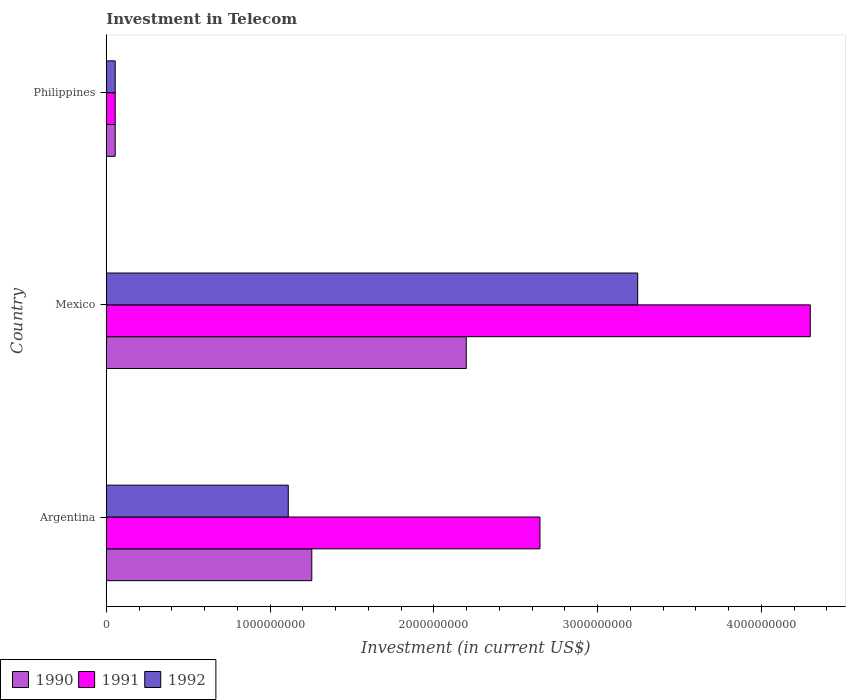How many groups of bars are there?
Offer a very short reply. 3. Are the number of bars on each tick of the Y-axis equal?
Your answer should be very brief. Yes. How many bars are there on the 3rd tick from the top?
Give a very brief answer. 3. What is the label of the 1st group of bars from the top?
Provide a succinct answer. Philippines. What is the amount invested in telecom in 1990 in Argentina?
Your response must be concise. 1.25e+09. Across all countries, what is the maximum amount invested in telecom in 1990?
Keep it short and to the point. 2.20e+09. Across all countries, what is the minimum amount invested in telecom in 1992?
Your answer should be compact. 5.42e+07. In which country was the amount invested in telecom in 1991 maximum?
Provide a short and direct response. Mexico. In which country was the amount invested in telecom in 1990 minimum?
Your answer should be very brief. Philippines. What is the total amount invested in telecom in 1992 in the graph?
Your response must be concise. 4.41e+09. What is the difference between the amount invested in telecom in 1992 in Mexico and that in Philippines?
Provide a short and direct response. 3.19e+09. What is the difference between the amount invested in telecom in 1992 in Philippines and the amount invested in telecom in 1991 in Mexico?
Ensure brevity in your answer.  -4.24e+09. What is the average amount invested in telecom in 1991 per country?
Make the answer very short. 2.33e+09. What is the difference between the amount invested in telecom in 1992 and amount invested in telecom in 1991 in Argentina?
Your response must be concise. -1.54e+09. What is the ratio of the amount invested in telecom in 1990 in Mexico to that in Philippines?
Your response must be concise. 40.55. Is the amount invested in telecom in 1992 in Argentina less than that in Philippines?
Give a very brief answer. No. Is the difference between the amount invested in telecom in 1992 in Argentina and Philippines greater than the difference between the amount invested in telecom in 1991 in Argentina and Philippines?
Offer a very short reply. No. What is the difference between the highest and the second highest amount invested in telecom in 1992?
Provide a succinct answer. 2.13e+09. What is the difference between the highest and the lowest amount invested in telecom in 1991?
Ensure brevity in your answer.  4.24e+09. Is it the case that in every country, the sum of the amount invested in telecom in 1992 and amount invested in telecom in 1991 is greater than the amount invested in telecom in 1990?
Make the answer very short. Yes. How many bars are there?
Offer a terse response. 9. Are all the bars in the graph horizontal?
Your answer should be very brief. Yes. What is the difference between two consecutive major ticks on the X-axis?
Offer a terse response. 1.00e+09. Are the values on the major ticks of X-axis written in scientific E-notation?
Offer a very short reply. No. Where does the legend appear in the graph?
Provide a succinct answer. Bottom left. What is the title of the graph?
Your response must be concise. Investment in Telecom. What is the label or title of the X-axis?
Ensure brevity in your answer.  Investment (in current US$). What is the label or title of the Y-axis?
Offer a terse response. Country. What is the Investment (in current US$) in 1990 in Argentina?
Your answer should be very brief. 1.25e+09. What is the Investment (in current US$) of 1991 in Argentina?
Offer a terse response. 2.65e+09. What is the Investment (in current US$) of 1992 in Argentina?
Offer a terse response. 1.11e+09. What is the Investment (in current US$) in 1990 in Mexico?
Provide a succinct answer. 2.20e+09. What is the Investment (in current US$) of 1991 in Mexico?
Make the answer very short. 4.30e+09. What is the Investment (in current US$) in 1992 in Mexico?
Your response must be concise. 3.24e+09. What is the Investment (in current US$) of 1990 in Philippines?
Ensure brevity in your answer.  5.42e+07. What is the Investment (in current US$) in 1991 in Philippines?
Your answer should be compact. 5.42e+07. What is the Investment (in current US$) of 1992 in Philippines?
Offer a terse response. 5.42e+07. Across all countries, what is the maximum Investment (in current US$) in 1990?
Ensure brevity in your answer.  2.20e+09. Across all countries, what is the maximum Investment (in current US$) of 1991?
Your answer should be very brief. 4.30e+09. Across all countries, what is the maximum Investment (in current US$) in 1992?
Your answer should be very brief. 3.24e+09. Across all countries, what is the minimum Investment (in current US$) in 1990?
Your answer should be very brief. 5.42e+07. Across all countries, what is the minimum Investment (in current US$) of 1991?
Provide a short and direct response. 5.42e+07. Across all countries, what is the minimum Investment (in current US$) in 1992?
Your response must be concise. 5.42e+07. What is the total Investment (in current US$) of 1990 in the graph?
Make the answer very short. 3.51e+09. What is the total Investment (in current US$) of 1991 in the graph?
Your response must be concise. 7.00e+09. What is the total Investment (in current US$) in 1992 in the graph?
Provide a succinct answer. 4.41e+09. What is the difference between the Investment (in current US$) in 1990 in Argentina and that in Mexico?
Keep it short and to the point. -9.43e+08. What is the difference between the Investment (in current US$) in 1991 in Argentina and that in Mexico?
Ensure brevity in your answer.  -1.65e+09. What is the difference between the Investment (in current US$) of 1992 in Argentina and that in Mexico?
Provide a succinct answer. -2.13e+09. What is the difference between the Investment (in current US$) of 1990 in Argentina and that in Philippines?
Provide a succinct answer. 1.20e+09. What is the difference between the Investment (in current US$) in 1991 in Argentina and that in Philippines?
Ensure brevity in your answer.  2.59e+09. What is the difference between the Investment (in current US$) in 1992 in Argentina and that in Philippines?
Give a very brief answer. 1.06e+09. What is the difference between the Investment (in current US$) of 1990 in Mexico and that in Philippines?
Make the answer very short. 2.14e+09. What is the difference between the Investment (in current US$) in 1991 in Mexico and that in Philippines?
Your response must be concise. 4.24e+09. What is the difference between the Investment (in current US$) in 1992 in Mexico and that in Philippines?
Make the answer very short. 3.19e+09. What is the difference between the Investment (in current US$) in 1990 in Argentina and the Investment (in current US$) in 1991 in Mexico?
Your answer should be compact. -3.04e+09. What is the difference between the Investment (in current US$) in 1990 in Argentina and the Investment (in current US$) in 1992 in Mexico?
Offer a very short reply. -1.99e+09. What is the difference between the Investment (in current US$) of 1991 in Argentina and the Investment (in current US$) of 1992 in Mexico?
Make the answer very short. -5.97e+08. What is the difference between the Investment (in current US$) of 1990 in Argentina and the Investment (in current US$) of 1991 in Philippines?
Offer a terse response. 1.20e+09. What is the difference between the Investment (in current US$) in 1990 in Argentina and the Investment (in current US$) in 1992 in Philippines?
Provide a succinct answer. 1.20e+09. What is the difference between the Investment (in current US$) in 1991 in Argentina and the Investment (in current US$) in 1992 in Philippines?
Keep it short and to the point. 2.59e+09. What is the difference between the Investment (in current US$) of 1990 in Mexico and the Investment (in current US$) of 1991 in Philippines?
Give a very brief answer. 2.14e+09. What is the difference between the Investment (in current US$) of 1990 in Mexico and the Investment (in current US$) of 1992 in Philippines?
Keep it short and to the point. 2.14e+09. What is the difference between the Investment (in current US$) in 1991 in Mexico and the Investment (in current US$) in 1992 in Philippines?
Give a very brief answer. 4.24e+09. What is the average Investment (in current US$) of 1990 per country?
Your answer should be compact. 1.17e+09. What is the average Investment (in current US$) in 1991 per country?
Provide a succinct answer. 2.33e+09. What is the average Investment (in current US$) in 1992 per country?
Offer a terse response. 1.47e+09. What is the difference between the Investment (in current US$) in 1990 and Investment (in current US$) in 1991 in Argentina?
Offer a terse response. -1.39e+09. What is the difference between the Investment (in current US$) of 1990 and Investment (in current US$) of 1992 in Argentina?
Your response must be concise. 1.44e+08. What is the difference between the Investment (in current US$) in 1991 and Investment (in current US$) in 1992 in Argentina?
Provide a short and direct response. 1.54e+09. What is the difference between the Investment (in current US$) in 1990 and Investment (in current US$) in 1991 in Mexico?
Your answer should be very brief. -2.10e+09. What is the difference between the Investment (in current US$) in 1990 and Investment (in current US$) in 1992 in Mexico?
Ensure brevity in your answer.  -1.05e+09. What is the difference between the Investment (in current US$) of 1991 and Investment (in current US$) of 1992 in Mexico?
Your response must be concise. 1.05e+09. What is the difference between the Investment (in current US$) in 1990 and Investment (in current US$) in 1991 in Philippines?
Offer a very short reply. 0. What is the difference between the Investment (in current US$) in 1990 and Investment (in current US$) in 1992 in Philippines?
Your response must be concise. 0. What is the difference between the Investment (in current US$) in 1991 and Investment (in current US$) in 1992 in Philippines?
Your answer should be very brief. 0. What is the ratio of the Investment (in current US$) of 1990 in Argentina to that in Mexico?
Provide a short and direct response. 0.57. What is the ratio of the Investment (in current US$) in 1991 in Argentina to that in Mexico?
Make the answer very short. 0.62. What is the ratio of the Investment (in current US$) of 1992 in Argentina to that in Mexico?
Offer a very short reply. 0.34. What is the ratio of the Investment (in current US$) of 1990 in Argentina to that in Philippines?
Your response must be concise. 23.15. What is the ratio of the Investment (in current US$) of 1991 in Argentina to that in Philippines?
Keep it short and to the point. 48.86. What is the ratio of the Investment (in current US$) in 1992 in Argentina to that in Philippines?
Keep it short and to the point. 20.5. What is the ratio of the Investment (in current US$) in 1990 in Mexico to that in Philippines?
Your answer should be compact. 40.55. What is the ratio of the Investment (in current US$) in 1991 in Mexico to that in Philippines?
Keep it short and to the point. 79.32. What is the ratio of the Investment (in current US$) in 1992 in Mexico to that in Philippines?
Ensure brevity in your answer.  59.87. What is the difference between the highest and the second highest Investment (in current US$) in 1990?
Ensure brevity in your answer.  9.43e+08. What is the difference between the highest and the second highest Investment (in current US$) of 1991?
Offer a very short reply. 1.65e+09. What is the difference between the highest and the second highest Investment (in current US$) in 1992?
Keep it short and to the point. 2.13e+09. What is the difference between the highest and the lowest Investment (in current US$) of 1990?
Your response must be concise. 2.14e+09. What is the difference between the highest and the lowest Investment (in current US$) of 1991?
Keep it short and to the point. 4.24e+09. What is the difference between the highest and the lowest Investment (in current US$) in 1992?
Keep it short and to the point. 3.19e+09. 